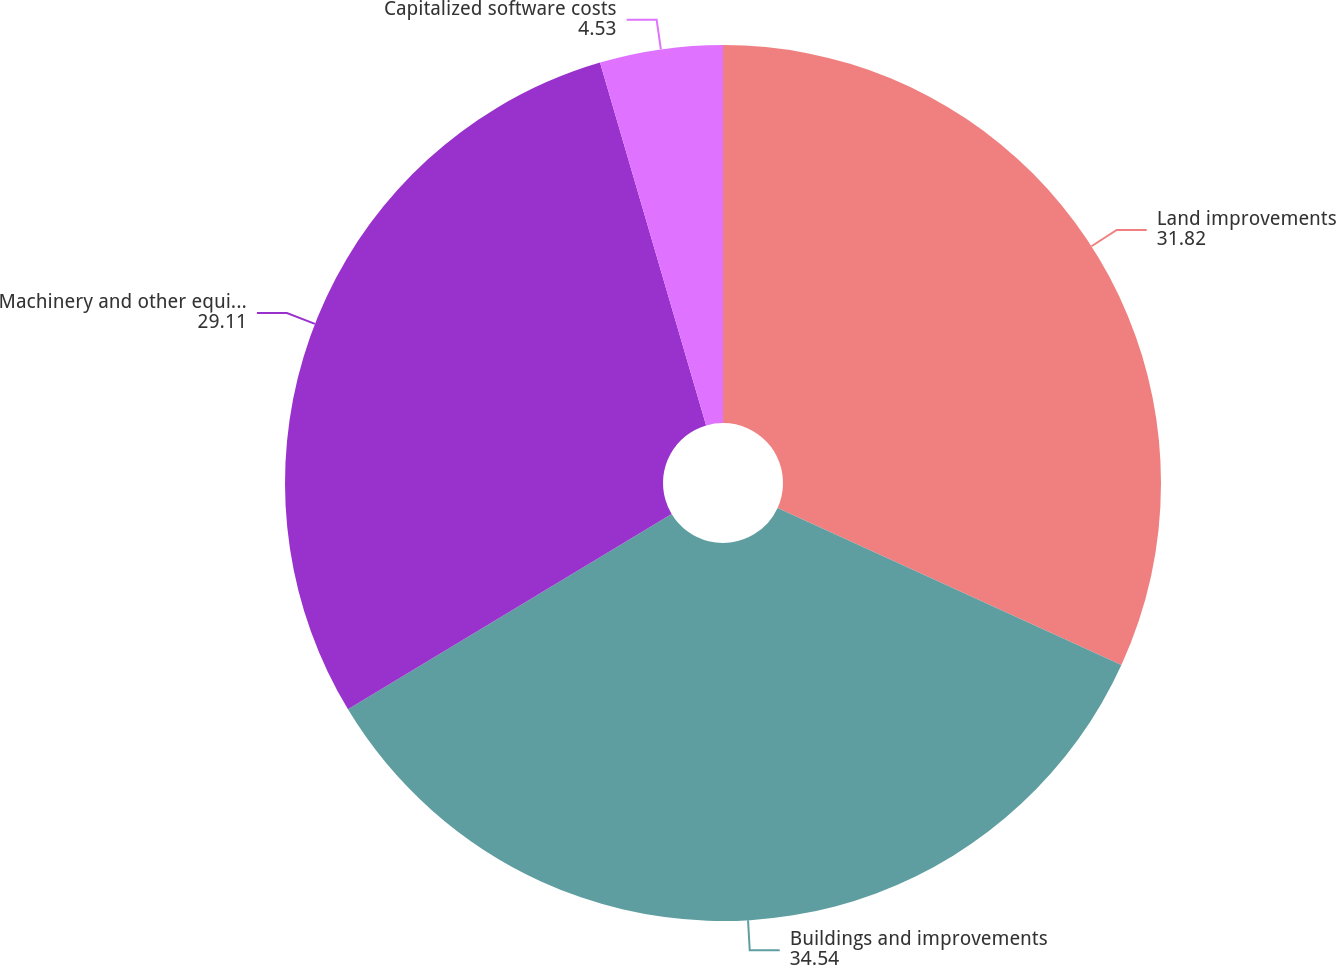Convert chart to OTSL. <chart><loc_0><loc_0><loc_500><loc_500><pie_chart><fcel>Land improvements<fcel>Buildings and improvements<fcel>Machinery and other equipment<fcel>Capitalized software costs<nl><fcel>31.82%<fcel>34.54%<fcel>29.11%<fcel>4.53%<nl></chart> 